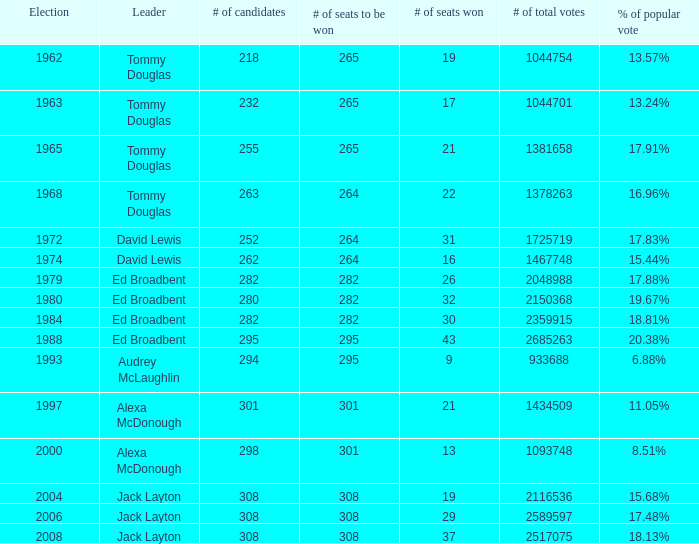Name the number of total votes for # of seats won being 30 2359915.0. 